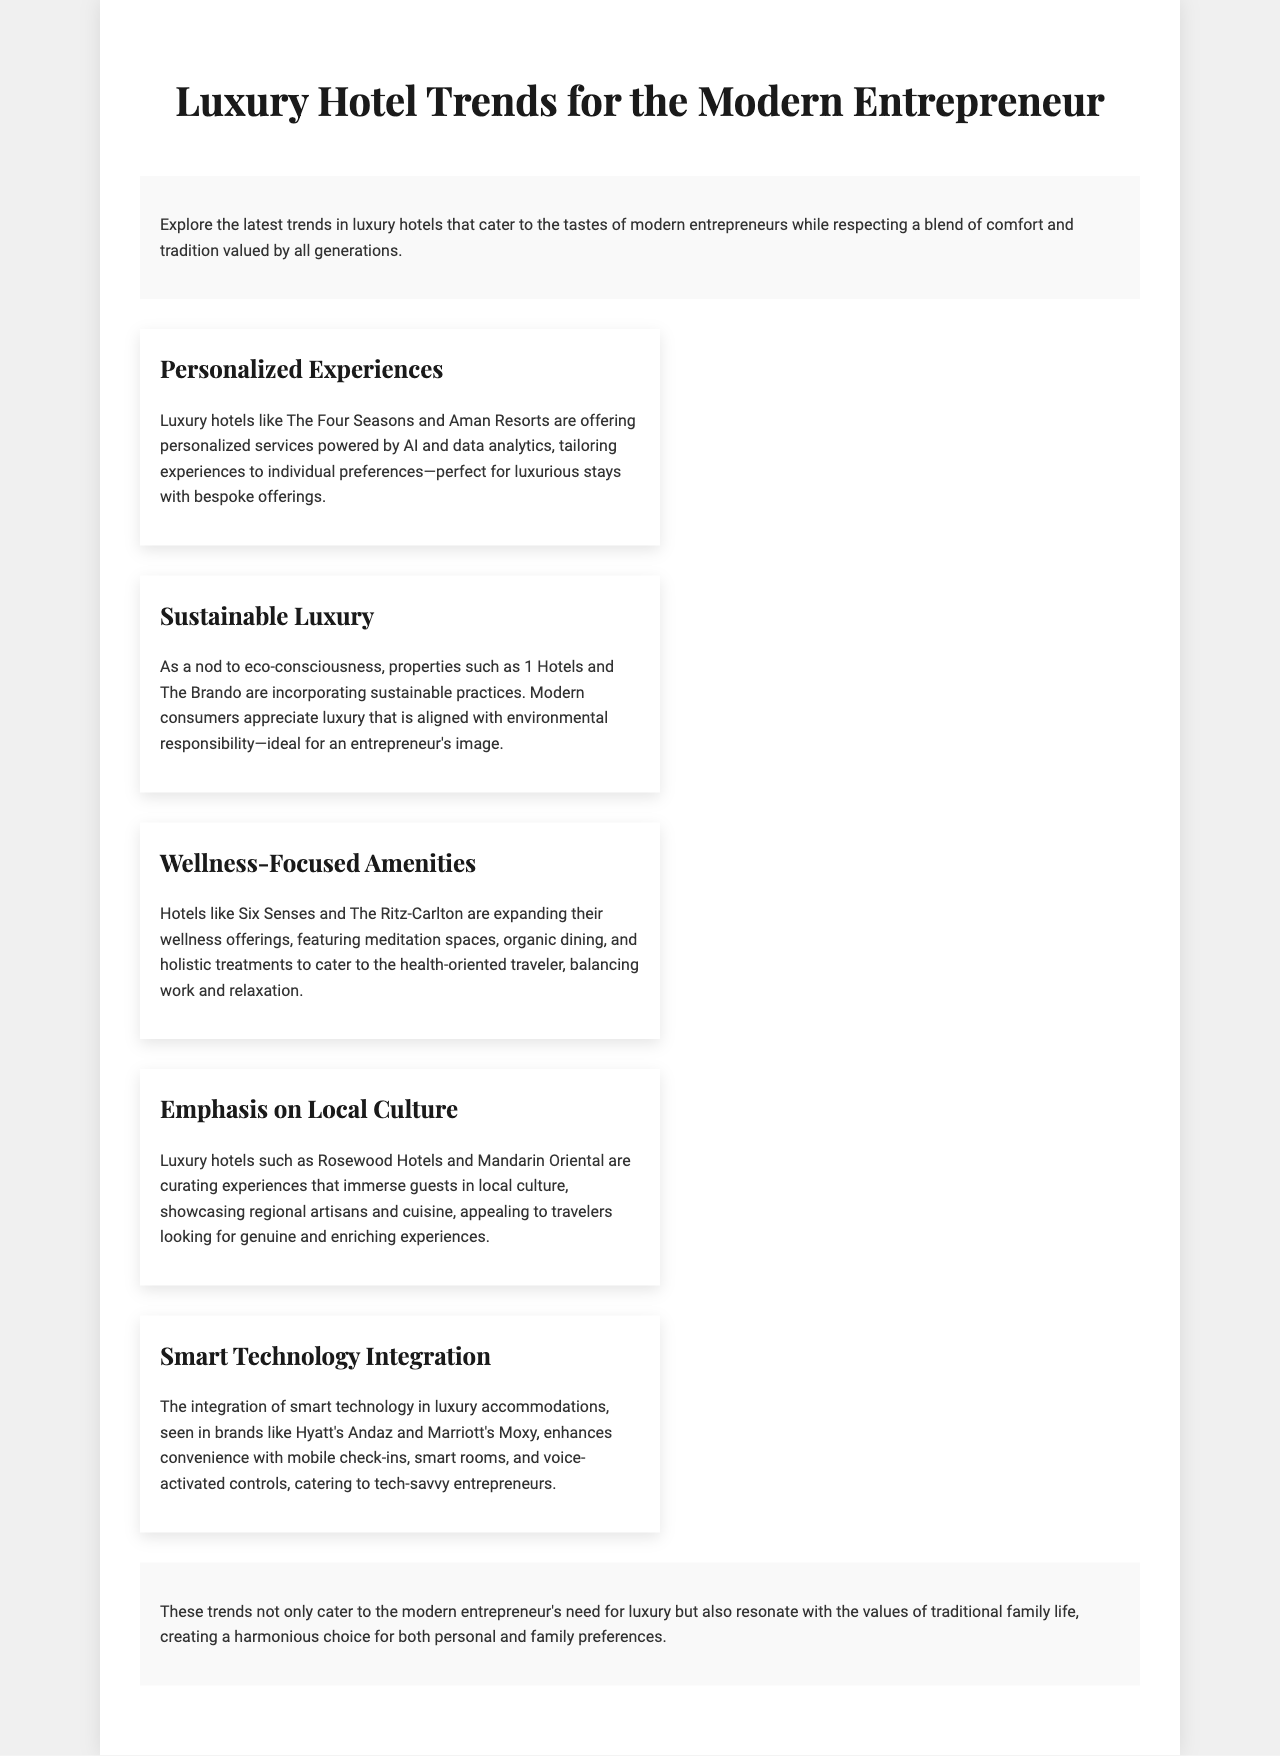What is the title of the brochure? The title of the brochure is prominently displayed at the top, indicating its focus on luxury hotel trends.
Answer: Luxury Hotel Trends for the Modern Entrepreneur Which hotel brands focus on personalized experiences? The section on personalized experiences lists specific hotel brands that offer these services, highlighting luxury choices.
Answer: The Four Seasons and Aman Resorts What type of luxury is emphasized in the context of sustainability? The document describes a trend emphasizing eco-consciousness in luxury hotels, showing a modern consumer perspective.
Answer: Sustainable Luxury Name one wellness-focused hotel mentioned in the brochure. The document lists specific hotels that focus on wellness amenities to attract health-oriented travelers.
Answer: Six Senses What technology integration is highlighted in luxury hotels? The document discusses the utilization of technology in hotel services, especially for convenience and modern amenities.
Answer: Smart Technology Integration Which type of offerings are included in the conclusion's perspective? The conclusion reflects on how trends harmonize luxury with traditional family values, integrating generational preferences.
Answer: Personal and family preferences Name one key aspect of local culture emphasized by luxury hotels. The document points out that luxury hotels are showcasing local artisans and cuisine, indicating a cultural immersion.
Answer: Local culture How are AI and data analytics related to luxury hotels? The document indicates that AI and data analytics are being implemented by hotels to tailor personalized experiences for guests.
Answer: Personalized services What type of amenities do wellness-focused hotels provide? The wellness-focused hotels are noted for specific health-oriented features that cater to guests looking for relaxation opportunities.
Answer: Meditation spaces and organic dining 